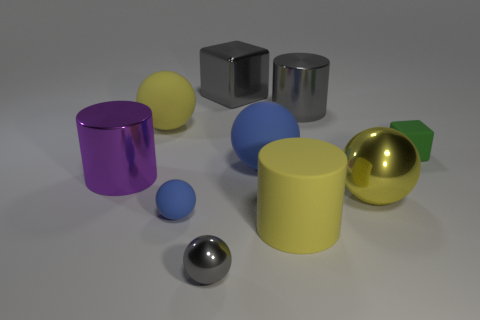Are there more big gray objects that are in front of the gray metallic cylinder than big yellow objects?
Give a very brief answer. No. What is the shape of the small rubber object that is to the right of the big thing behind the big metal cylinder behind the matte block?
Provide a succinct answer. Cube. There is a gray shiny object in front of the yellow shiny object; is it the same shape as the yellow rubber object that is in front of the small blue matte ball?
Ensure brevity in your answer.  No. How many blocks are either large purple rubber things or large purple objects?
Give a very brief answer. 0. Are the tiny green thing and the large blue object made of the same material?
Offer a very short reply. Yes. What number of other objects are the same color as the big rubber cylinder?
Ensure brevity in your answer.  2. The big yellow matte thing that is in front of the tiny green matte cube has what shape?
Your answer should be compact. Cylinder. How many objects are either blue matte objects or big purple cylinders?
Your answer should be very brief. 3. Do the purple object and the gray object in front of the big metallic sphere have the same size?
Give a very brief answer. No. How many other things are there of the same material as the purple cylinder?
Offer a terse response. 4. 